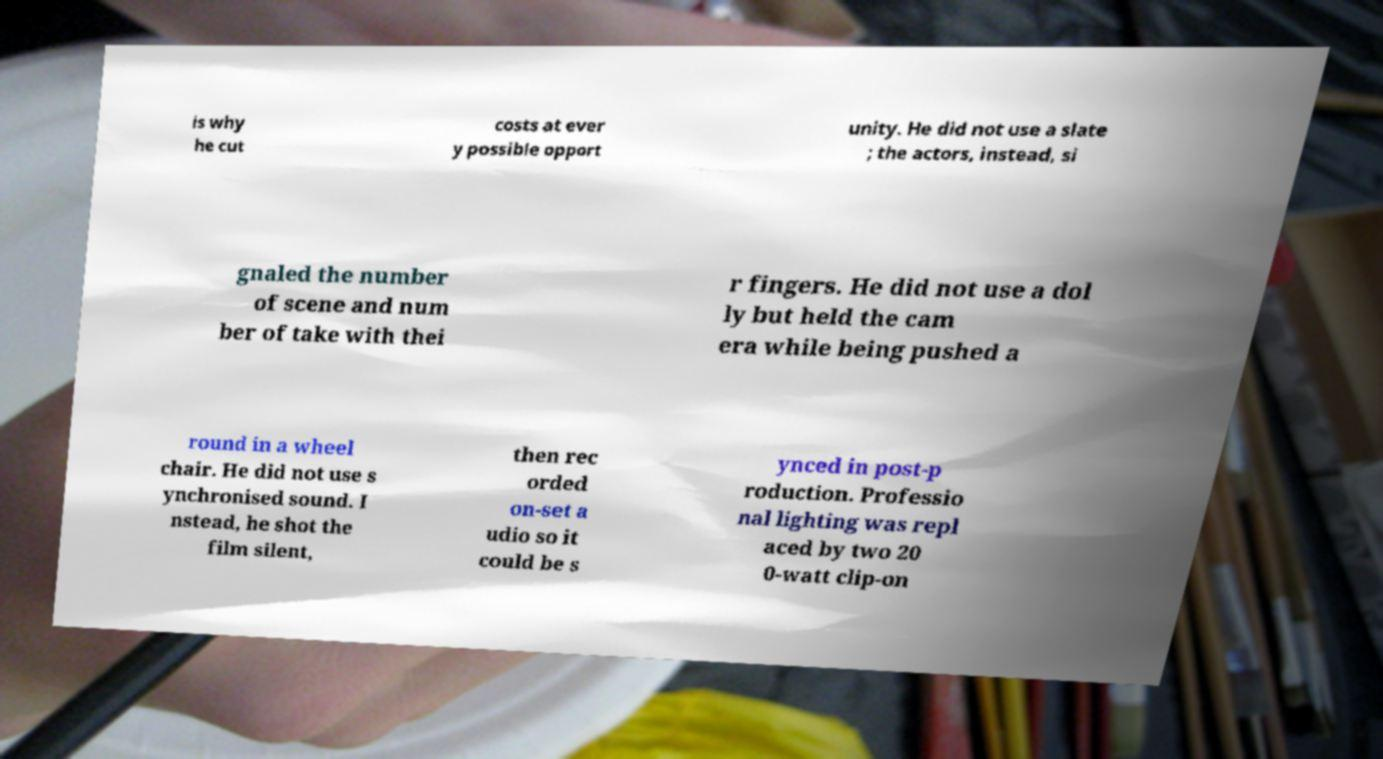What messages or text are displayed in this image? I need them in a readable, typed format. is why he cut costs at ever y possible opport unity. He did not use a slate ; the actors, instead, si gnaled the number of scene and num ber of take with thei r fingers. He did not use a dol ly but held the cam era while being pushed a round in a wheel chair. He did not use s ynchronised sound. I nstead, he shot the film silent, then rec orded on-set a udio so it could be s ynced in post-p roduction. Professio nal lighting was repl aced by two 20 0-watt clip-on 